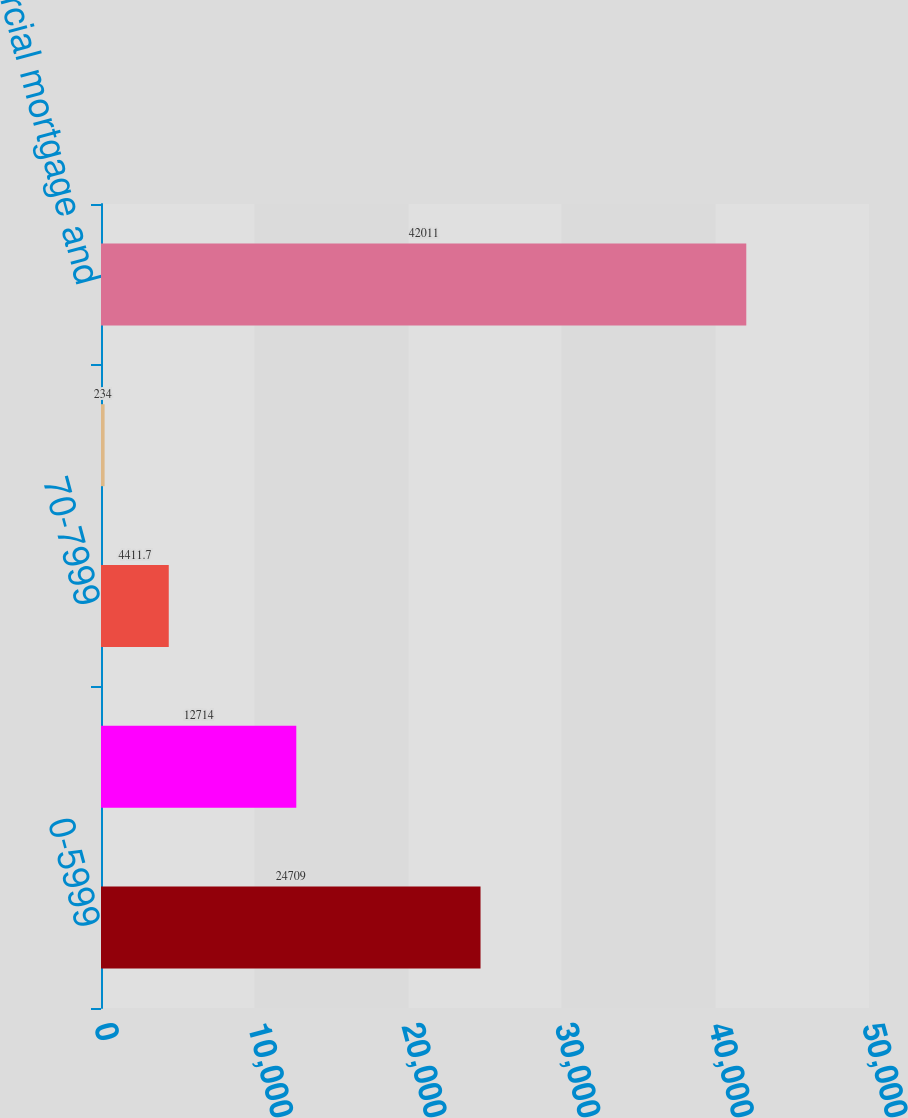Convert chart. <chart><loc_0><loc_0><loc_500><loc_500><bar_chart><fcel>0-5999<fcel>60-6999<fcel>70-7999<fcel>Greater than 80<fcel>Total commercial mortgage and<nl><fcel>24709<fcel>12714<fcel>4411.7<fcel>234<fcel>42011<nl></chart> 